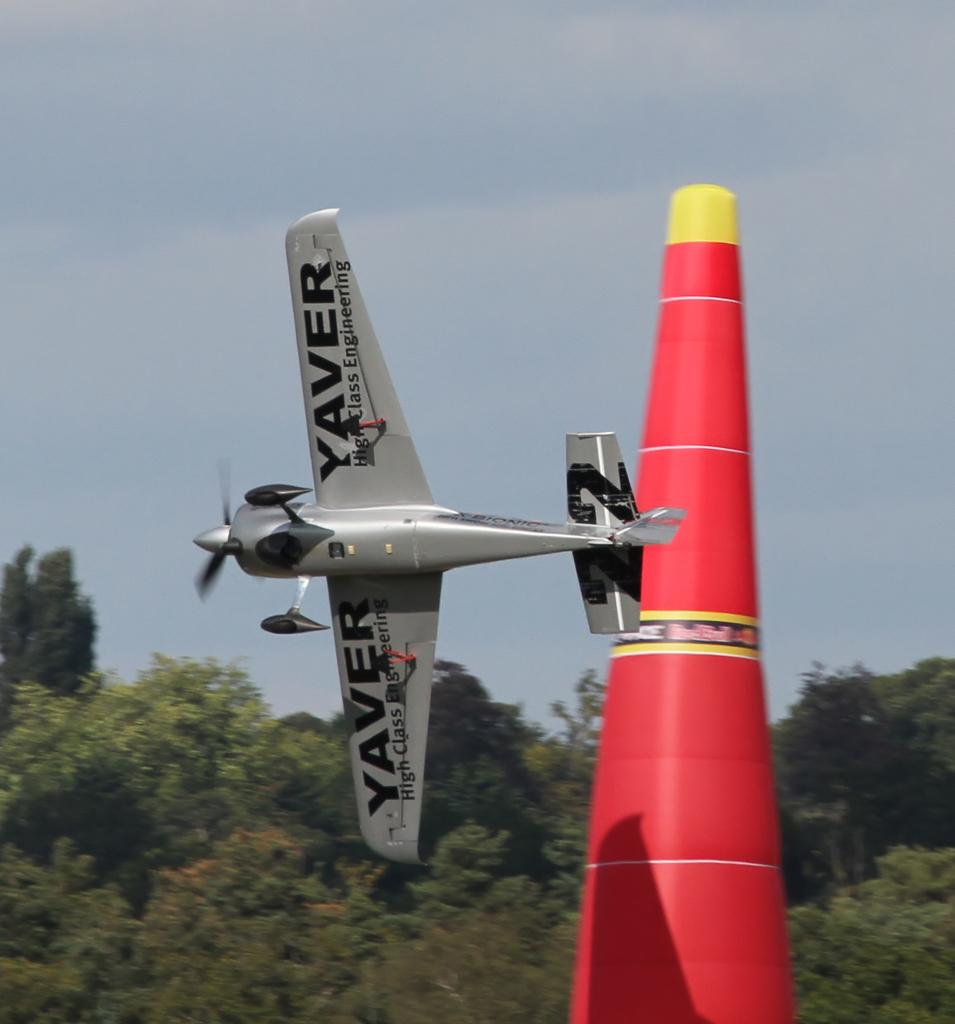<image>
Share a concise interpretation of the image provided. a Yaver plane is cutting hard around a red cone 